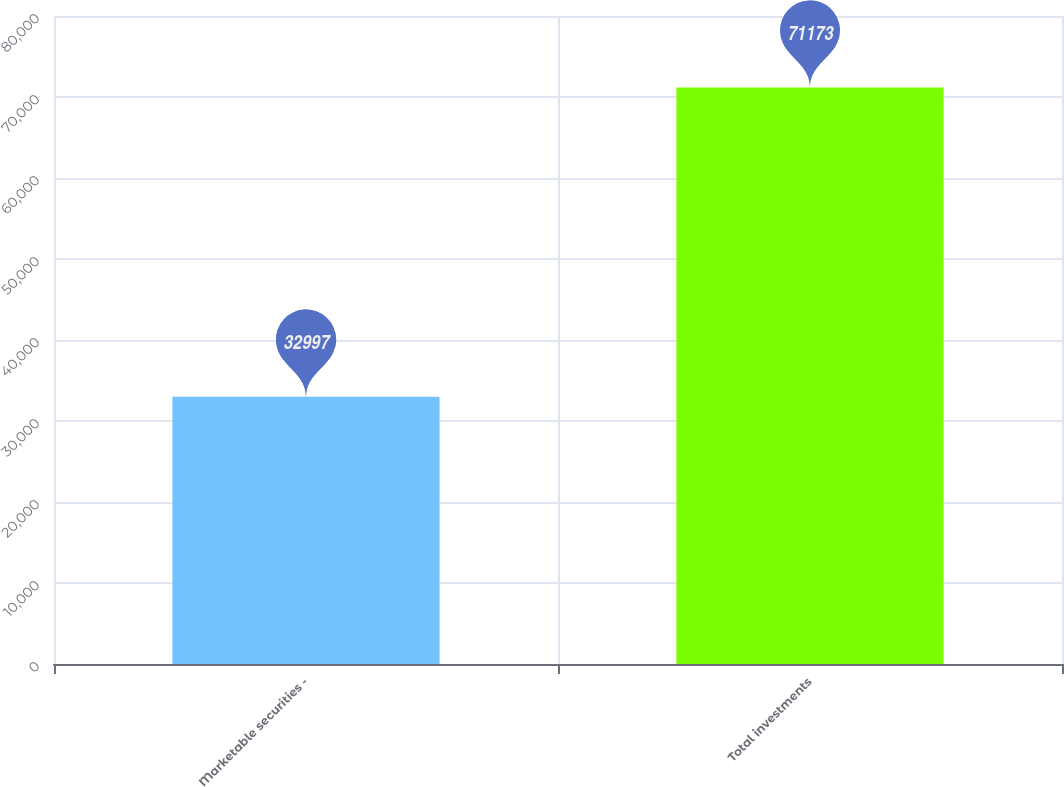Convert chart. <chart><loc_0><loc_0><loc_500><loc_500><bar_chart><fcel>Marketable securities -<fcel>Total investments<nl><fcel>32997<fcel>71173<nl></chart> 